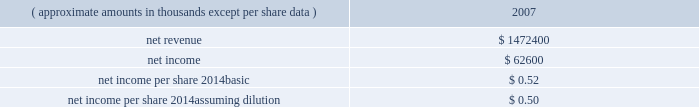Hologic , inc .
Notes to consolidated financial statements ( continued ) ( in thousands , except per share data ) failure of the company to develop new products and product enhancements on a timely basis or within budget could harm the company 2019s results of operations and financial condition .
For additional risks that may affect the company 2019s business and prospects following completion of the merger , see 201crisk factors 201d in item 1a of the company 2019s form 10-k for the year ended september 29 , 2007 .
Goodwill the preliminary purchase price allocation has resulted in goodwill of approximately $ 3895100 .
The factors contributing to the recognition of this amount of goodwill are based upon several strategic and synergistic benefits that are expected to be realized from the combination .
These benefits include the expectation that the company 2019s complementary products and technologies will create a leading women 2019s healthcare company with an enhanced presence in hospitals , private practices and healthcare organizations .
The company also expects to realize substantial synergies through the use of cytyc 2019s ob/gyn and breast surgeon sales channel to cross-sell the company 2019s existing and future products .
The merger provides the company broader channel coverage within the united states and expanded geographic reach internationally , as well as increased scale and scope for further expanding operations through product development and complementary strategic transactions .
Supplemental unaudited pro-forma information the following unaudited pro forma information presents the consolidated results of operations of the company and cytyc as if the acquisitions had occurred at the beginning of fiscal 2007 , with pro forma adjustments to give effect to amortization of intangible assets , an increase in interest expense on acquisition financing and certain other adjustments together with related tax effects: .
The $ 368200 charge for acquired in-process research and development that was a direct result of the transaction is excluded from the unaudited pro forma information above .
The unaudited pro forma results are not necessarily indicative of the results that the company would have attained had the acquisitions of cytyc occurred at the beginning of the periods presented .
Prior to the close of the merger the board of directors of both hologic and cytyc approved a modification to certain outstanding equity awards for cytyc employees .
The modification provided for the acceleration of vesting upon the close of merger for those awards that did not provide for acceleration upon a change of control as part of the original terms of the award .
This modification was made so that the company will not incur stock based compensation charges that it otherwise would have if the awards had continued to vest under their original terms .
Credit agreement on october 22 , 2007 , company and certain of its domestic subsidiaries , entered into a senior secured credit agreement with goldman sachs credit partners l.p .
And certain other lenders , ( collectively , the 201clenders 201d ) .
Pursuant to the terms and conditions of the credit agreement , the lenders have committed to provide senior secured financing in an aggregate amount of up to $ 2550000 .
As of the closing of the cytyc merger , the company borrowed $ 2350000 under the credit facilities. .
What would be the net profit margin in 2007 assuming that acquisitions of the company and cytyc at the beginning of fiscal 2007? 
Computations: (62600 / 1472400)
Answer: 0.04252. 